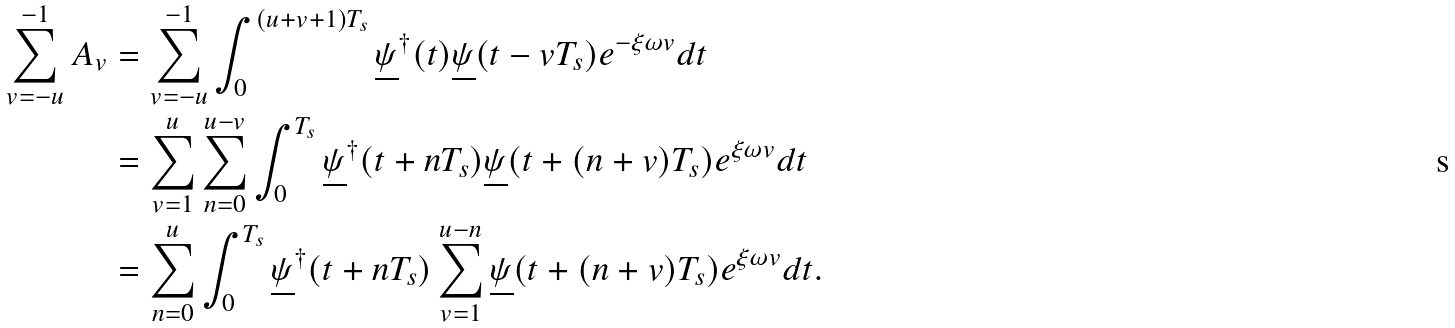Convert formula to latex. <formula><loc_0><loc_0><loc_500><loc_500>\sum _ { v = - u } ^ { - 1 } A _ { v } & = \sum _ { v = - u } ^ { - 1 } \int _ { 0 } ^ { ( u + v + 1 ) T _ { s } } \underline { \psi } ^ { \dagger } ( t ) \underline { \psi } ( t - v T _ { s } ) e ^ { - \xi \omega v } d t \\ & = \sum _ { v = 1 } ^ { u } \sum _ { n = 0 } ^ { u - v } \int _ { 0 } ^ { T _ { s } } \underline { \psi } ^ { \dagger } ( t + n T _ { s } ) \underline { \psi } ( t + ( n + v ) T _ { s } ) e ^ { \xi \omega v } d t \\ & = \sum _ { n = 0 } ^ { u } \int _ { 0 } ^ { T _ { s } } \underline { \psi } ^ { \dagger } ( t + n T _ { s } ) \sum _ { v = 1 } ^ { u - n } \underline { \psi } ( t + ( n + v ) T _ { s } ) e ^ { \xi \omega v } d t .</formula> 